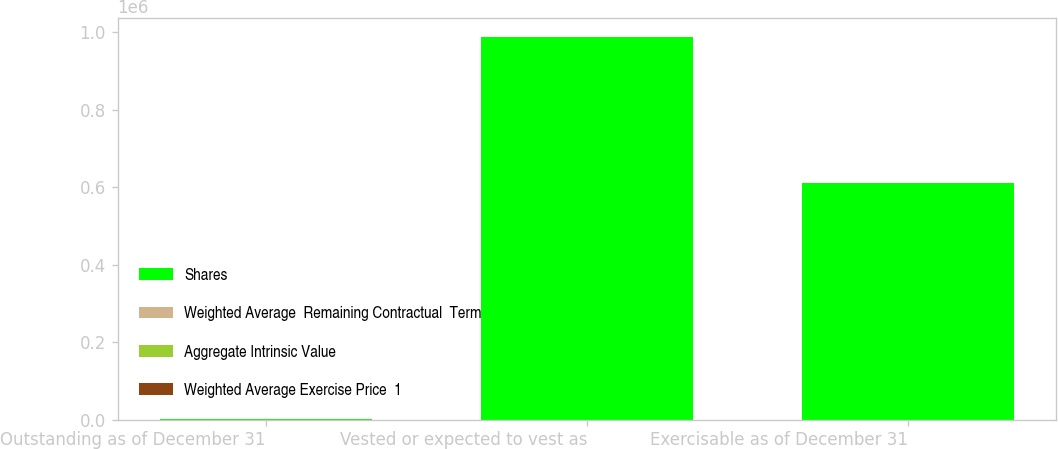Convert chart. <chart><loc_0><loc_0><loc_500><loc_500><stacked_bar_chart><ecel><fcel>Outstanding as of December 31<fcel>Vested or expected to vest as<fcel>Exercisable as of December 31<nl><fcel>Shares<fcel>40<fcel>988391<fcel>611443<nl><fcel>Weighted Average  Remaining Contractual  Term<fcel>158.9<fcel>158.01<fcel>146.35<nl><fcel>Aggregate Intrinsic Value<fcel>6.8<fcel>6.7<fcel>5.9<nl><fcel>Weighted Average Exercise Price  1<fcel>40<fcel>39<fcel>31<nl></chart> 